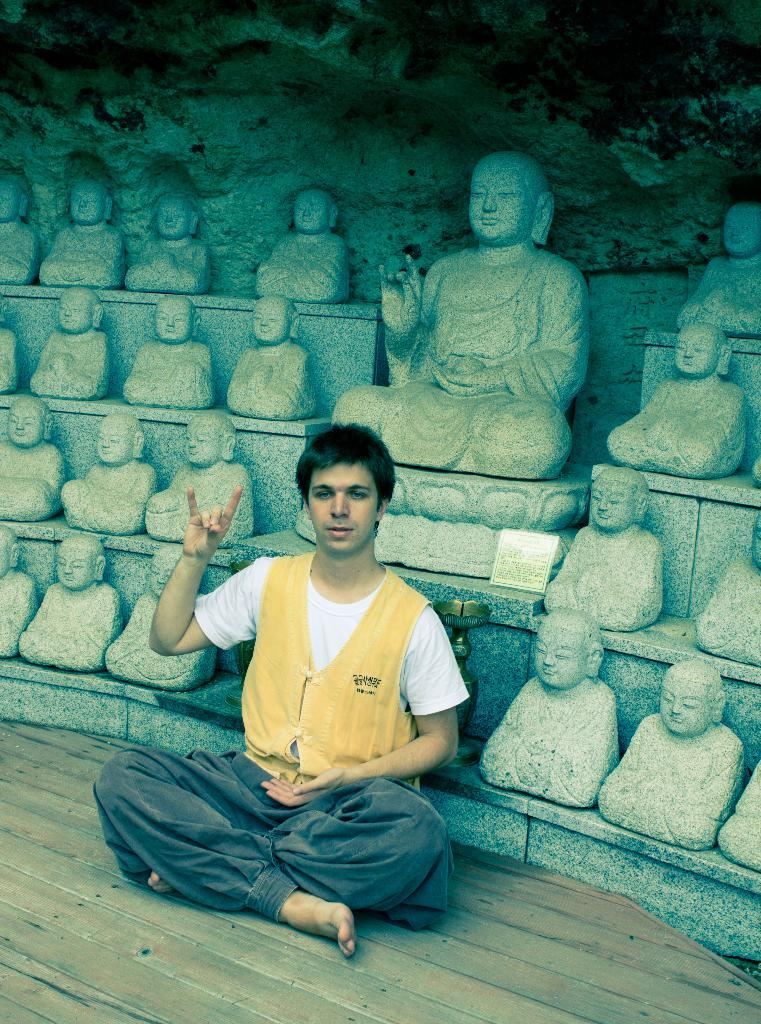What is the person in the image doing? The person is sitting on the ground in the image. What can be seen in the background of the image? There is a group of statues, a stand, and a board with some text in the background of the image. What type of reward is the person holding in the image? There is no reward visible in the image; the person is simply sitting on the ground. 